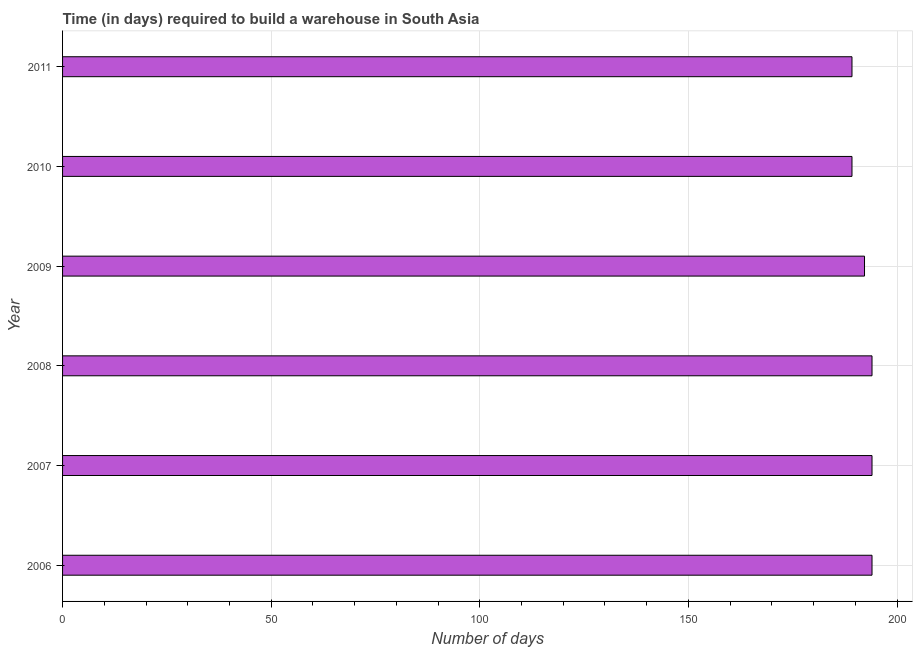What is the title of the graph?
Your answer should be very brief. Time (in days) required to build a warehouse in South Asia. What is the label or title of the X-axis?
Keep it short and to the point. Number of days. What is the label or title of the Y-axis?
Offer a very short reply. Year. What is the time required to build a warehouse in 2010?
Make the answer very short. 189.2. Across all years, what is the maximum time required to build a warehouse?
Provide a succinct answer. 194. Across all years, what is the minimum time required to build a warehouse?
Give a very brief answer. 189.2. What is the sum of the time required to build a warehouse?
Your answer should be compact. 1152.6. What is the difference between the time required to build a warehouse in 2007 and 2009?
Keep it short and to the point. 1.8. What is the average time required to build a warehouse per year?
Make the answer very short. 192.1. What is the median time required to build a warehouse?
Ensure brevity in your answer.  193.1. In how many years, is the time required to build a warehouse greater than 190 days?
Give a very brief answer. 4. Do a majority of the years between 2008 and 2011 (inclusive) have time required to build a warehouse greater than 90 days?
Your answer should be very brief. Yes. What is the ratio of the time required to build a warehouse in 2008 to that in 2011?
Provide a succinct answer. 1.02. Is the time required to build a warehouse in 2008 less than that in 2010?
Keep it short and to the point. No. Is the difference between the time required to build a warehouse in 2008 and 2011 greater than the difference between any two years?
Make the answer very short. Yes. What is the difference between the highest and the second highest time required to build a warehouse?
Your answer should be very brief. 0. How many bars are there?
Your answer should be compact. 6. Are all the bars in the graph horizontal?
Offer a terse response. Yes. What is the Number of days in 2006?
Make the answer very short. 194. What is the Number of days in 2007?
Provide a succinct answer. 194. What is the Number of days in 2008?
Keep it short and to the point. 194. What is the Number of days in 2009?
Ensure brevity in your answer.  192.2. What is the Number of days in 2010?
Your response must be concise. 189.2. What is the Number of days in 2011?
Make the answer very short. 189.2. What is the difference between the Number of days in 2006 and 2009?
Ensure brevity in your answer.  1.8. What is the difference between the Number of days in 2006 and 2010?
Provide a short and direct response. 4.8. What is the difference between the Number of days in 2007 and 2008?
Offer a terse response. 0. What is the difference between the Number of days in 2007 and 2009?
Give a very brief answer. 1.8. What is the difference between the Number of days in 2007 and 2010?
Give a very brief answer. 4.8. What is the difference between the Number of days in 2008 and 2009?
Your response must be concise. 1.8. What is the difference between the Number of days in 2008 and 2010?
Your answer should be very brief. 4.8. What is the difference between the Number of days in 2008 and 2011?
Your answer should be compact. 4.8. What is the difference between the Number of days in 2009 and 2010?
Your answer should be very brief. 3. What is the difference between the Number of days in 2010 and 2011?
Ensure brevity in your answer.  0. What is the ratio of the Number of days in 2006 to that in 2008?
Give a very brief answer. 1. What is the ratio of the Number of days in 2007 to that in 2008?
Provide a succinct answer. 1. What is the ratio of the Number of days in 2008 to that in 2009?
Your response must be concise. 1.01. What is the ratio of the Number of days in 2008 to that in 2010?
Offer a terse response. 1.02. What is the ratio of the Number of days in 2008 to that in 2011?
Your answer should be very brief. 1.02. What is the ratio of the Number of days in 2009 to that in 2010?
Provide a succinct answer. 1.02. What is the ratio of the Number of days in 2009 to that in 2011?
Your answer should be very brief. 1.02. 